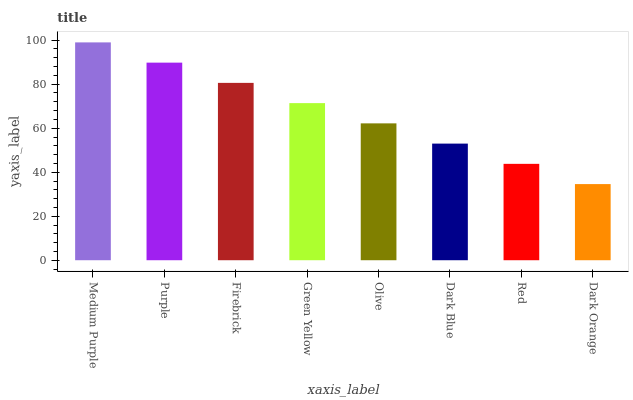Is Dark Orange the minimum?
Answer yes or no. Yes. Is Medium Purple the maximum?
Answer yes or no. Yes. Is Purple the minimum?
Answer yes or no. No. Is Purple the maximum?
Answer yes or no. No. Is Medium Purple greater than Purple?
Answer yes or no. Yes. Is Purple less than Medium Purple?
Answer yes or no. Yes. Is Purple greater than Medium Purple?
Answer yes or no. No. Is Medium Purple less than Purple?
Answer yes or no. No. Is Green Yellow the high median?
Answer yes or no. Yes. Is Olive the low median?
Answer yes or no. Yes. Is Red the high median?
Answer yes or no. No. Is Dark Orange the low median?
Answer yes or no. No. 